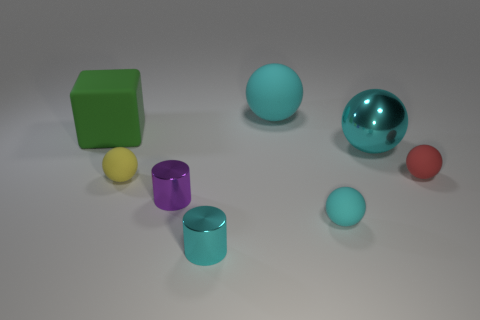What is the shape of the other shiny thing that is the same color as the big metal object?
Provide a succinct answer. Cylinder. Is the number of small red cylinders greater than the number of cyan shiny cylinders?
Your response must be concise. No. What shape is the metallic thing that is behind the yellow ball?
Your response must be concise. Sphere. What number of purple metal objects have the same shape as the tiny red rubber thing?
Keep it short and to the point. 0. There is a cyan metallic object that is left of the rubber sphere that is behind the red matte ball; what size is it?
Give a very brief answer. Small. What number of red things are small cylinders or big shiny balls?
Offer a terse response. 0. Are there fewer purple metal objects right of the small cyan ball than cyan metal cylinders that are behind the yellow matte thing?
Provide a short and direct response. No. Is the size of the cyan cylinder the same as the cyan matte sphere behind the tiny cyan rubber object?
Give a very brief answer. No. What number of green matte objects have the same size as the green block?
Make the answer very short. 0. What number of small objects are matte balls or cyan things?
Provide a succinct answer. 4. 